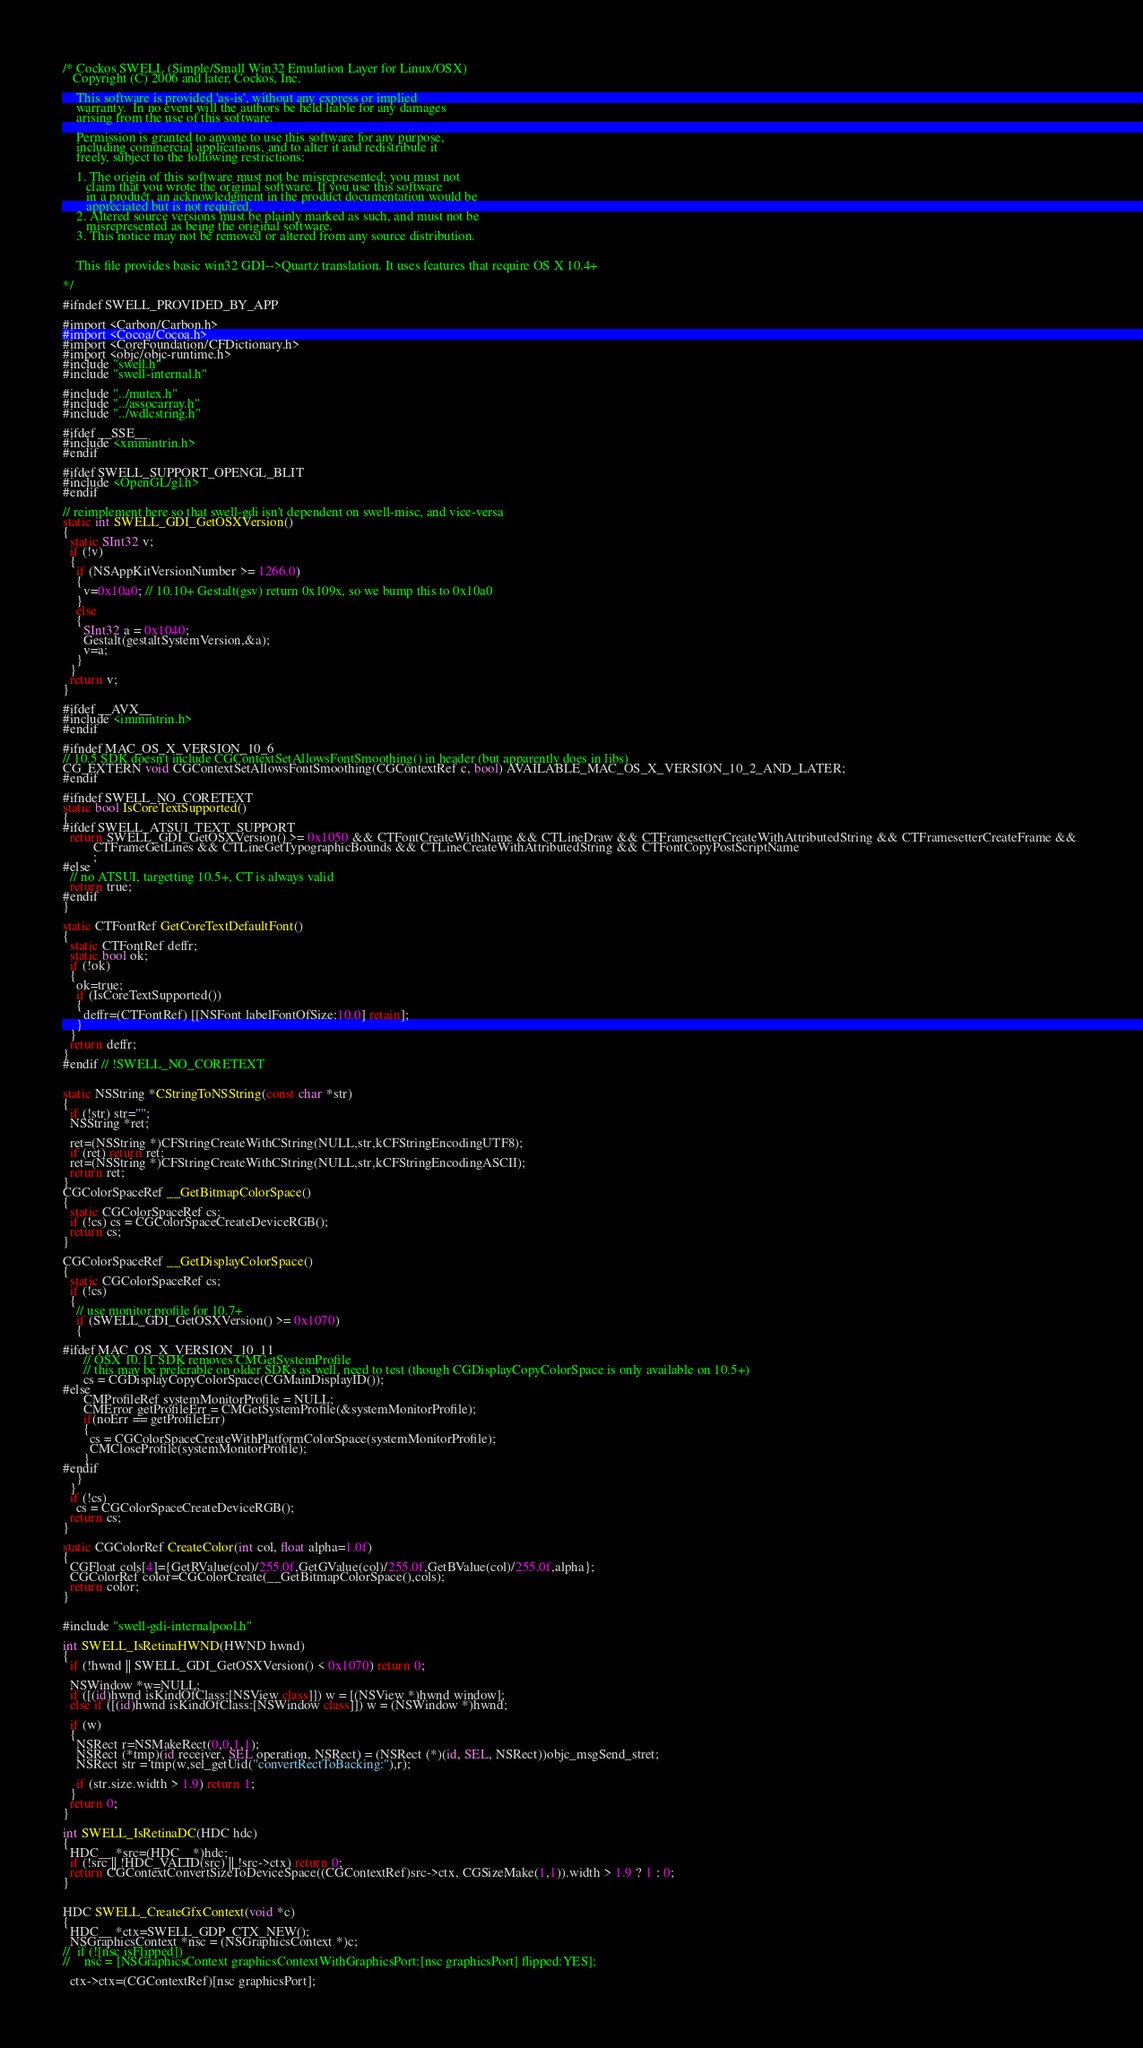Convert code to text. <code><loc_0><loc_0><loc_500><loc_500><_ObjectiveC_>/* Cockos SWELL (Simple/Small Win32 Emulation Layer for Linux/OSX)
   Copyright (C) 2006 and later, Cockos, Inc.

    This software is provided 'as-is', without any express or implied
    warranty.  In no event will the authors be held liable for any damages
    arising from the use of this software.

    Permission is granted to anyone to use this software for any purpose,
    including commercial applications, and to alter it and redistribute it
    freely, subject to the following restrictions:

    1. The origin of this software must not be misrepresented; you must not
       claim that you wrote the original software. If you use this software
       in a product, an acknowledgment in the product documentation would be
       appreciated but is not required.
    2. Altered source versions must be plainly marked as such, and must not be
       misrepresented as being the original software.
    3. This notice may not be removed or altered from any source distribution.
  

    This file provides basic win32 GDI-->Quartz translation. It uses features that require OS X 10.4+

*/

#ifndef SWELL_PROVIDED_BY_APP

#import <Carbon/Carbon.h>
#import <Cocoa/Cocoa.h>
#import <CoreFoundation/CFDictionary.h>
#import <objc/objc-runtime.h>
#include "swell.h"
#include "swell-internal.h"

#include "../mutex.h"
#include "../assocarray.h"
#include "../wdlcstring.h"

#ifdef __SSE__
#include <xmmintrin.h>
#endif

#ifdef SWELL_SUPPORT_OPENGL_BLIT
#include <OpenGL/gl.h>
#endif

// reimplement here so that swell-gdi isn't dependent on swell-misc, and vice-versa
static int SWELL_GDI_GetOSXVersion()
{
  static SInt32 v;
  if (!v)
  {
    if (NSAppKitVersionNumber >= 1266.0) 
    {
      v=0x10a0; // 10.10+ Gestalt(gsv) return 0x109x, so we bump this to 0x10a0
    }
    else 
    {
      SInt32 a = 0x1040;
      Gestalt(gestaltSystemVersion,&a);
      v=a;
    }
  }
  return v;
}

#ifdef __AVX__
#include <immintrin.h>
#endif

#ifndef MAC_OS_X_VERSION_10_6
// 10.5 SDK doesn't include CGContextSetAllowsFontSmoothing() in header (but apparently does in libs)
CG_EXTERN void CGContextSetAllowsFontSmoothing(CGContextRef c, bool) AVAILABLE_MAC_OS_X_VERSION_10_2_AND_LATER;
#endif

#ifndef SWELL_NO_CORETEXT
static bool IsCoreTextSupported()
{
#ifdef SWELL_ATSUI_TEXT_SUPPORT
  return SWELL_GDI_GetOSXVersion() >= 0x1050 && CTFontCreateWithName && CTLineDraw && CTFramesetterCreateWithAttributedString && CTFramesetterCreateFrame && 
         CTFrameGetLines && CTLineGetTypographicBounds && CTLineCreateWithAttributedString && CTFontCopyPostScriptName
         ;
#else
  // no ATSUI, targetting 10.5+, CT is always valid
  return true;
#endif
}

static CTFontRef GetCoreTextDefaultFont()
{
  static CTFontRef deffr;
  static bool ok;
  if (!ok)
  {
    ok=true;
    if (IsCoreTextSupported())
    {
      deffr=(CTFontRef) [[NSFont labelFontOfSize:10.0] retain]; 
    }
  }
  return deffr;
}
#endif // !SWELL_NO_CORETEXT
  

static NSString *CStringToNSString(const char *str)
{
  if (!str) str="";
  NSString *ret;
  
  ret=(NSString *)CFStringCreateWithCString(NULL,str,kCFStringEncodingUTF8);
  if (ret) return ret;
  ret=(NSString *)CFStringCreateWithCString(NULL,str,kCFStringEncodingASCII);
  return ret;
}
CGColorSpaceRef __GetBitmapColorSpace()
{
  static CGColorSpaceRef cs;
  if (!cs) cs = CGColorSpaceCreateDeviceRGB();
  return cs;
}

CGColorSpaceRef __GetDisplayColorSpace()
{
  static CGColorSpaceRef cs;
  if (!cs)
  {
    // use monitor profile for 10.7+
    if (SWELL_GDI_GetOSXVersion() >= 0x1070)
    {

#ifdef MAC_OS_X_VERSION_10_11
      // OSX 10.11 SDK removes CMGetSystemProfile
      // this may be preferable on older SDKs as well, need to test (though CGDisplayCopyColorSpace is only available on 10.5+)
      cs = CGDisplayCopyColorSpace(CGMainDisplayID());
#else
      CMProfileRef systemMonitorProfile = NULL;
      CMError getProfileErr = CMGetSystemProfile(&systemMonitorProfile);
      if(noErr == getProfileErr)
      {
        cs = CGColorSpaceCreateWithPlatformColorSpace(systemMonitorProfile);
        CMCloseProfile(systemMonitorProfile);
      }
#endif
    }
  }
  if (!cs) 
    cs = CGColorSpaceCreateDeviceRGB();
  return cs;
}

static CGColorRef CreateColor(int col, float alpha=1.0f)
{
  CGFloat cols[4]={GetRValue(col)/255.0f,GetGValue(col)/255.0f,GetBValue(col)/255.0f,alpha};
  CGColorRef color=CGColorCreate(__GetBitmapColorSpace(),cols);
  return color;
}


#include "swell-gdi-internalpool.h"

int SWELL_IsRetinaHWND(HWND hwnd)
{
  if (!hwnd || SWELL_GDI_GetOSXVersion() < 0x1070) return 0;

  NSWindow *w=NULL;
  if ([(id)hwnd isKindOfClass:[NSView class]]) w = [(NSView *)hwnd window];
  else if ([(id)hwnd isKindOfClass:[NSWindow class]]) w = (NSWindow *)hwnd;

  if (w)
  {
    NSRect r=NSMakeRect(0,0,1,1);
    NSRect (*tmp)(id receiver, SEL operation, NSRect) = (NSRect (*)(id, SEL, NSRect))objc_msgSend_stret;
    NSRect str = tmp(w,sel_getUid("convertRectToBacking:"),r);

    if (str.size.width > 1.9) return 1;
  }
  return 0;
}

int SWELL_IsRetinaDC(HDC hdc)
{
  HDC__ *src=(HDC__*)hdc;
  if (!src || !HDC_VALID(src) || !src->ctx) return 0;
  return CGContextConvertSizeToDeviceSpace((CGContextRef)src->ctx, CGSizeMake(1,1)).width > 1.9 ? 1 : 0;
}


HDC SWELL_CreateGfxContext(void *c)
{
  HDC__ *ctx=SWELL_GDP_CTX_NEW();
  NSGraphicsContext *nsc = (NSGraphicsContext *)c;
//  if (![nsc isFlipped])
//    nsc = [NSGraphicsContext graphicsContextWithGraphicsPort:[nsc graphicsPort] flipped:YES];

  ctx->ctx=(CGContextRef)[nsc graphicsPort];</code> 